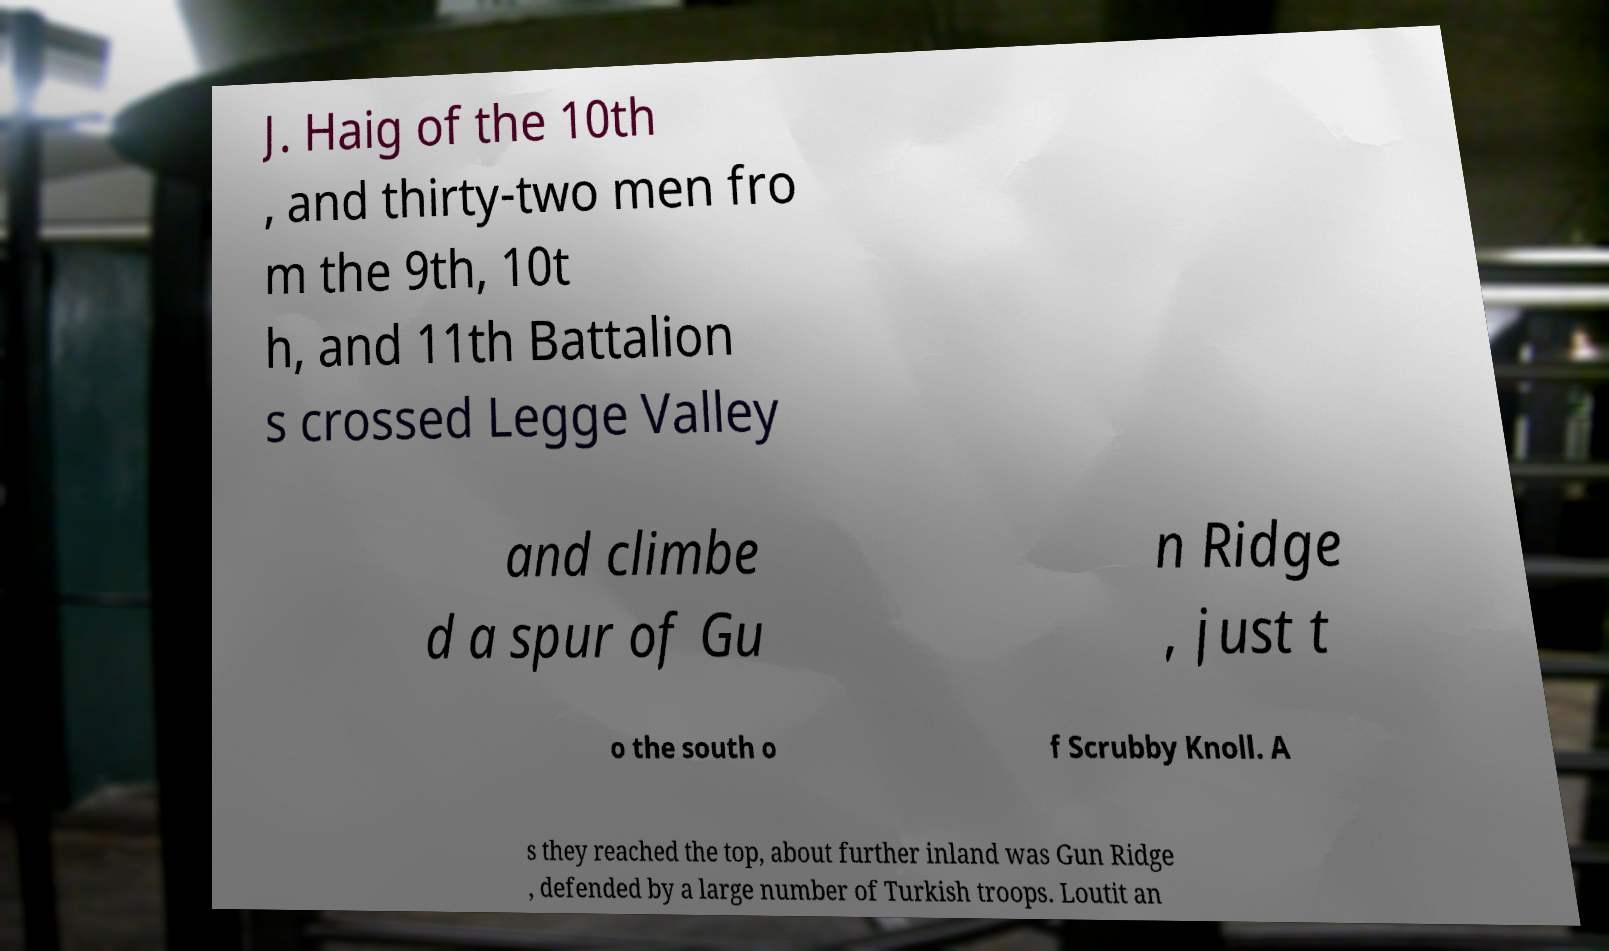Please identify and transcribe the text found in this image. J. Haig of the 10th , and thirty-two men fro m the 9th, 10t h, and 11th Battalion s crossed Legge Valley and climbe d a spur of Gu n Ridge , just t o the south o f Scrubby Knoll. A s they reached the top, about further inland was Gun Ridge , defended by a large number of Turkish troops. Loutit an 